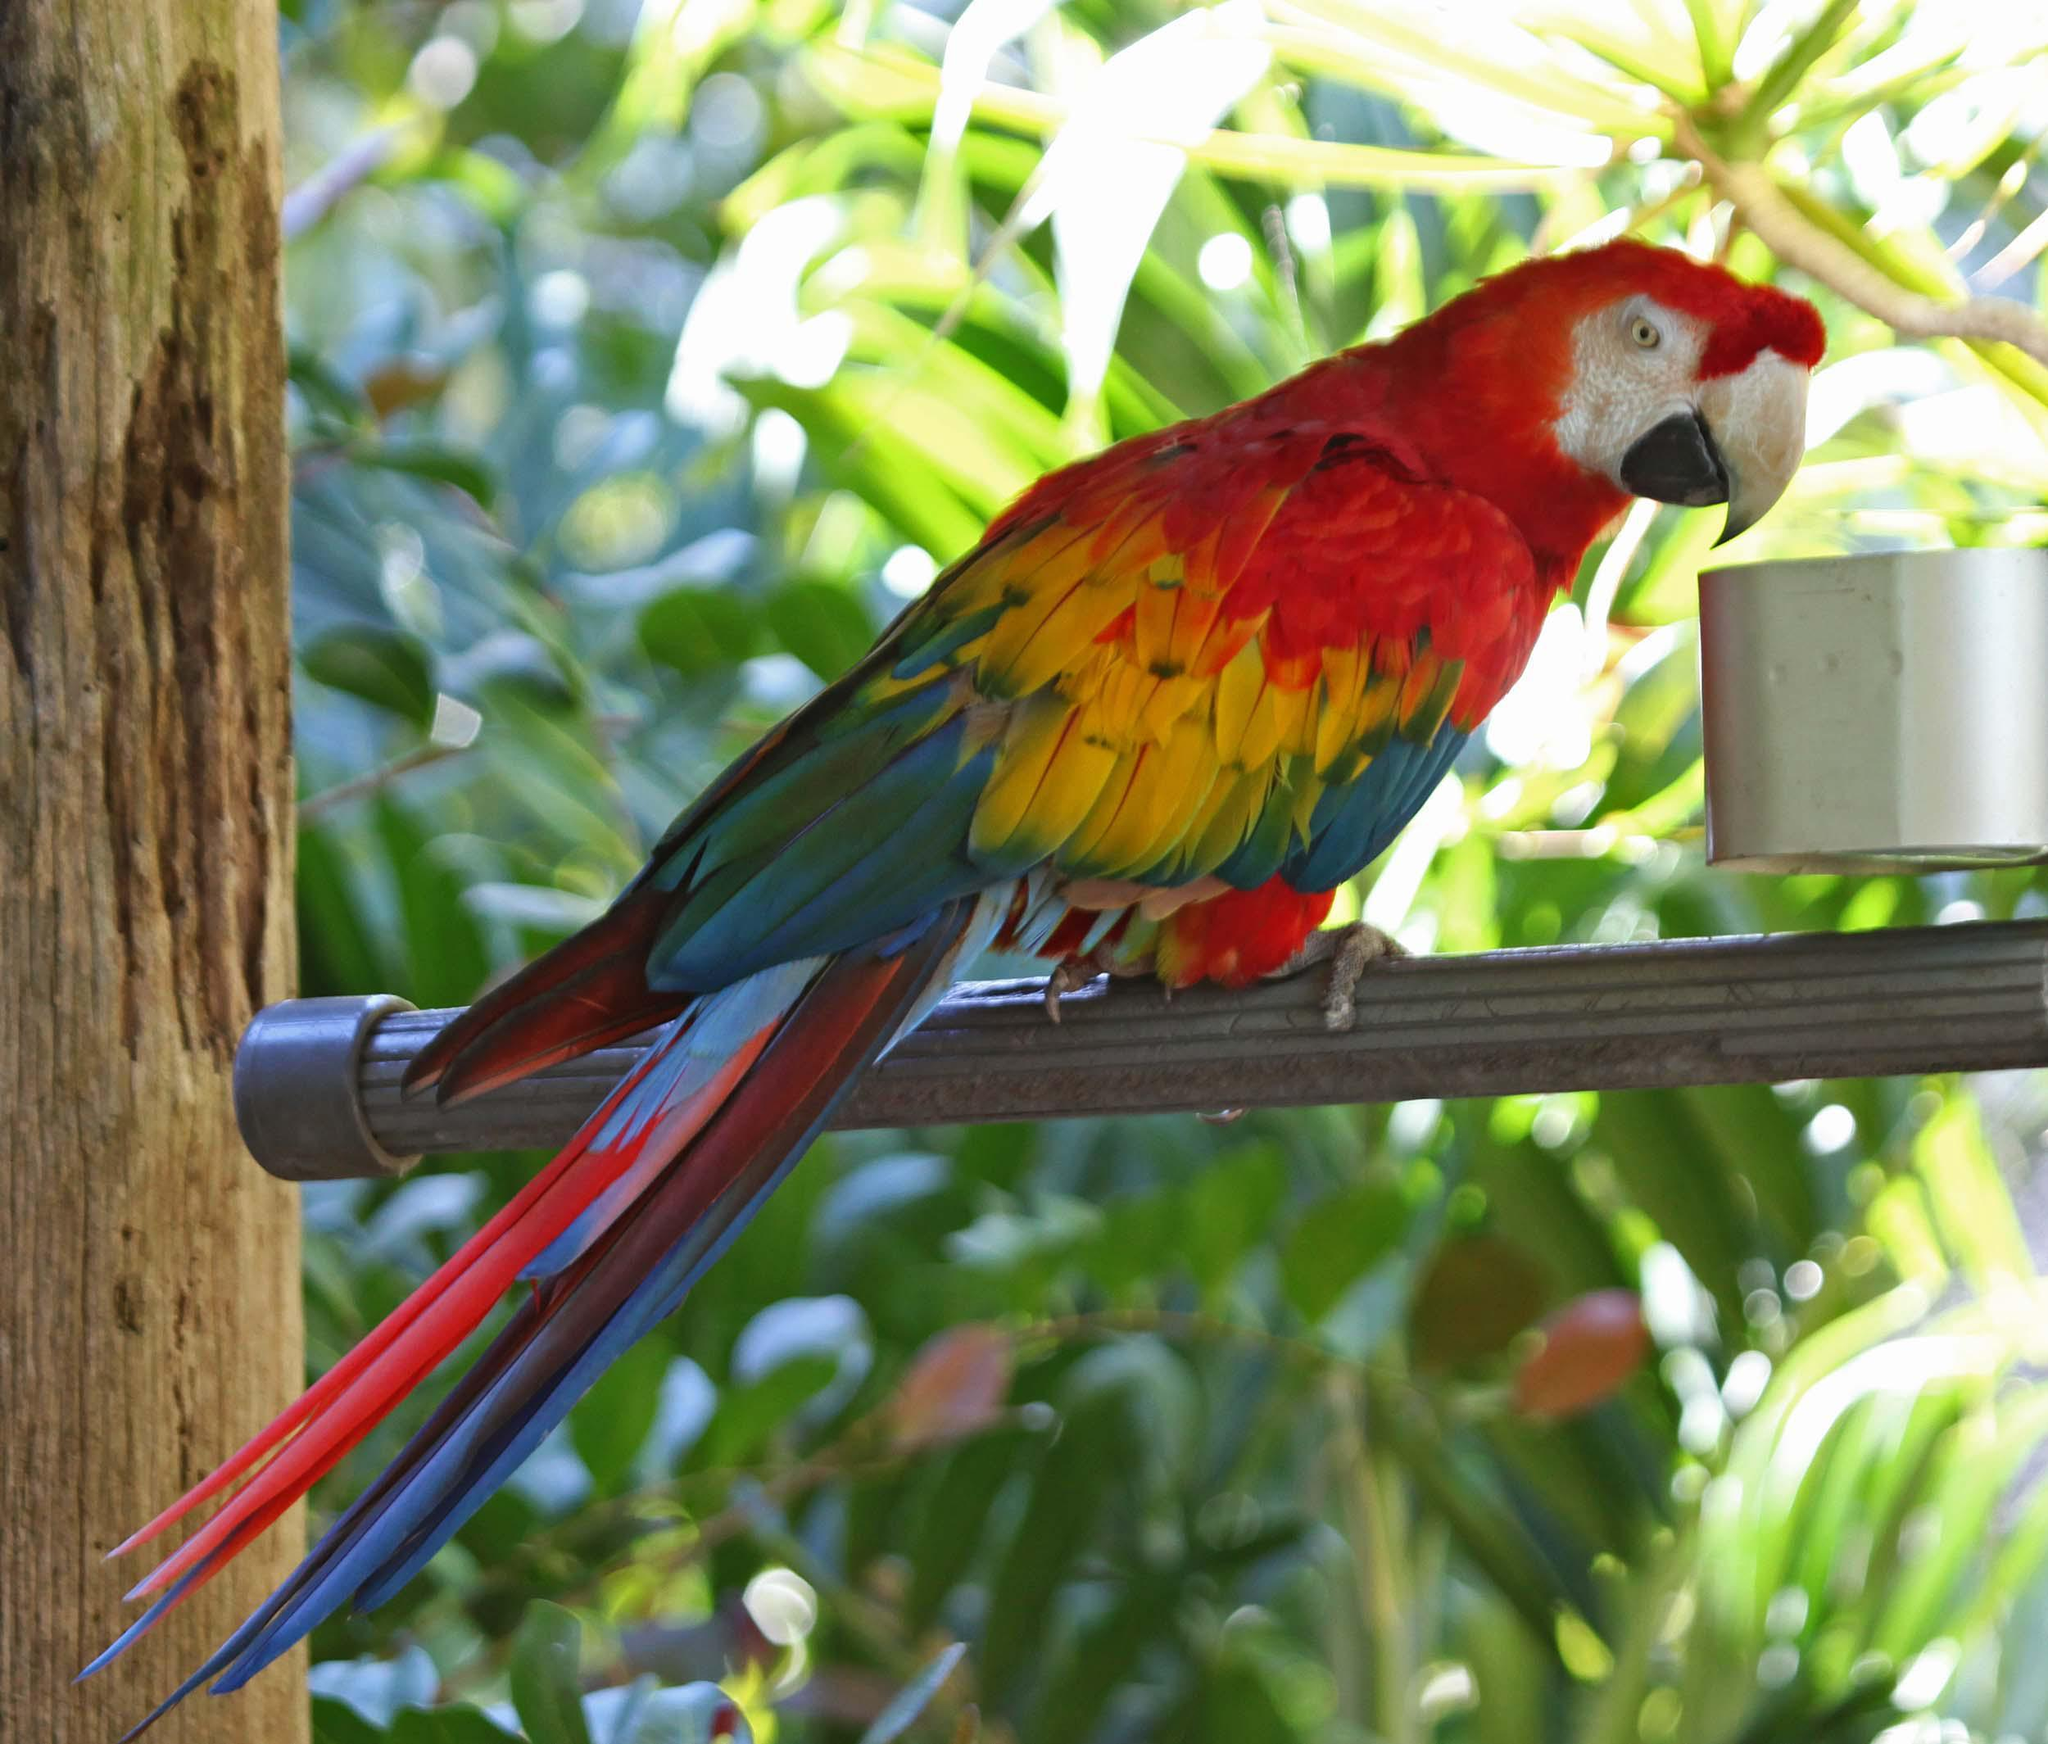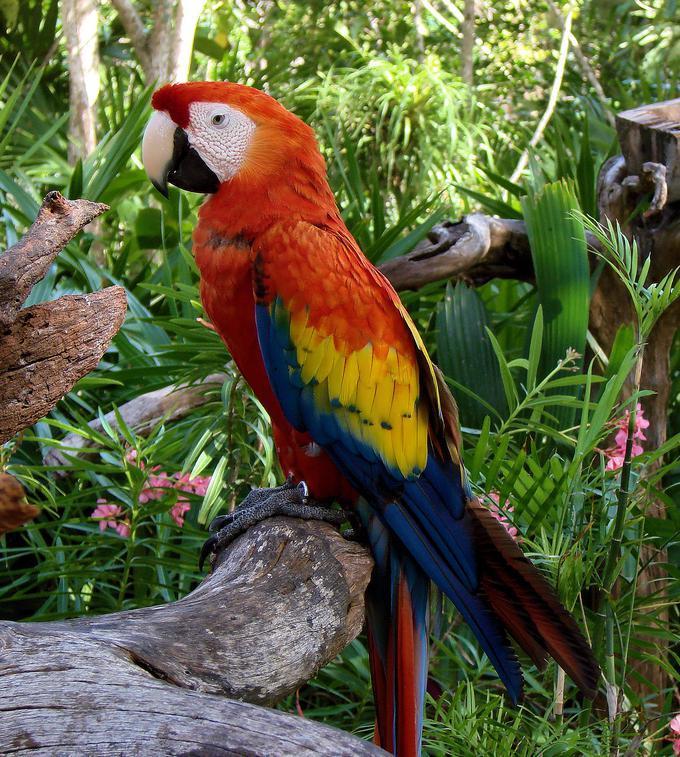The first image is the image on the left, the second image is the image on the right. Assess this claim about the two images: "There are exactly two birds in the image on the right.". Correct or not? Answer yes or no. No. The first image is the image on the left, the second image is the image on the right. Given the left and right images, does the statement "There are only two birds and neither of them is flying." hold true? Answer yes or no. Yes. The first image is the image on the left, the second image is the image on the right. Analyze the images presented: Is the assertion "There are exactly two birds in the image on the right." valid? Answer yes or no. No. The first image is the image on the left, the second image is the image on the right. Evaluate the accuracy of this statement regarding the images: "In one image, two parrots are sitting together, but facing different directions.". Is it true? Answer yes or no. No. 